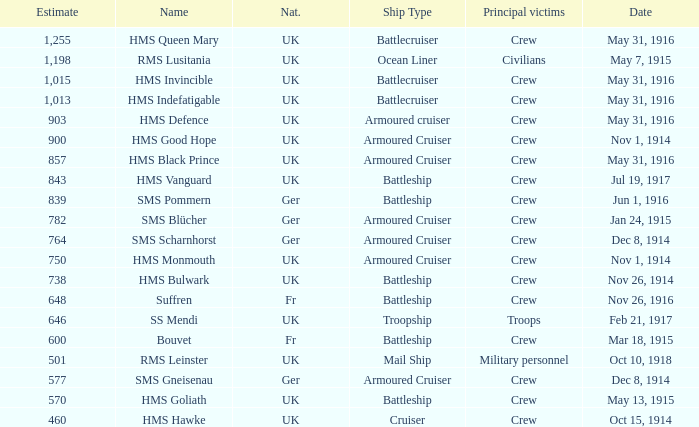What is the name of the battleship with the battle listed on may 13, 1915? HMS Goliath. 